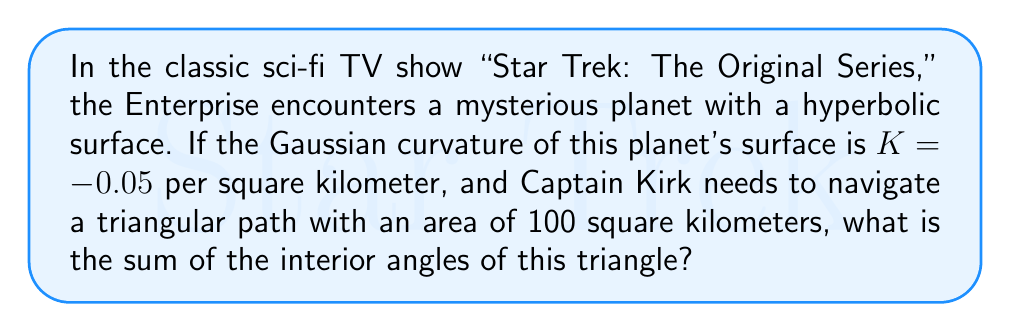Give your solution to this math problem. Let's approach this step-by-step using concepts from hyperbolic geometry:

1) In hyperbolic geometry, the sum of the interior angles of a triangle is less than 180°. The difference between 180° and the actual sum is called the defect.

2) The Gauss-Bonnet theorem relates the area of a hyperbolic triangle to its angle defect and the Gaussian curvature of the surface. The formula is:

   $$ A = \frac{\pi - (\alpha + \beta + \gamma)}{|K|} $$

   Where $A$ is the area, $K$ is the Gaussian curvature, and $\alpha$, $\beta$, and $\gamma$ are the interior angles of the triangle.

3) We're given:
   - Gaussian curvature $K = -0.05$ per km²
   - Area $A = 100$ km²

4) Let's substitute these into the formula:

   $$ 100 = \frac{\pi - (\alpha + \beta + \gamma)}{|-0.05|} $$

5) Simplify:
   $$ 100 = \frac{\pi - (\alpha + \beta + \gamma)}{0.05} $$

6) Multiply both sides by 0.05:
   $$ 5 = \pi - (\alpha + \beta + \gamma) $$

7) Subtract both sides from $\pi$:
   $$ \pi - 5 = \alpha + \beta + \gamma $$

8) Calculate:
   $$ \alpha + \beta + \gamma = 3.14159... - 5 = -1.85840... \text{ radians} $$

9) Convert to degrees:
   $$ -1.85840... \text{ radians} \times \frac{180°}{\pi} = -106.47°  $$

10) The sum of the interior angles is therefore:
    $$ 180° - 106.47° = 73.53° $$
Answer: 73.53° 